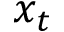Convert formula to latex. <formula><loc_0><loc_0><loc_500><loc_500>x _ { t }</formula> 